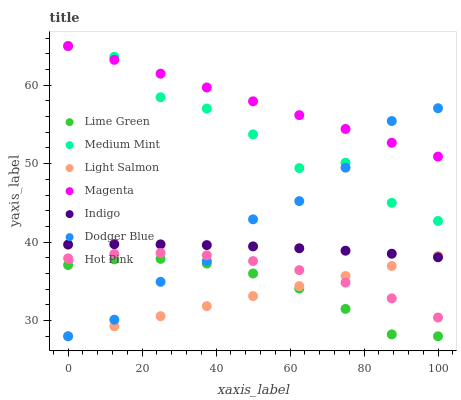Does Light Salmon have the minimum area under the curve?
Answer yes or no. Yes. Does Magenta have the maximum area under the curve?
Answer yes or no. Yes. Does Indigo have the minimum area under the curve?
Answer yes or no. No. Does Indigo have the maximum area under the curve?
Answer yes or no. No. Is Light Salmon the smoothest?
Answer yes or no. Yes. Is Medium Mint the roughest?
Answer yes or no. Yes. Is Indigo the smoothest?
Answer yes or no. No. Is Indigo the roughest?
Answer yes or no. No. Does Light Salmon have the lowest value?
Answer yes or no. Yes. Does Indigo have the lowest value?
Answer yes or no. No. Does Magenta have the highest value?
Answer yes or no. Yes. Does Light Salmon have the highest value?
Answer yes or no. No. Is Hot Pink less than Magenta?
Answer yes or no. Yes. Is Magenta greater than Lime Green?
Answer yes or no. Yes. Does Indigo intersect Light Salmon?
Answer yes or no. Yes. Is Indigo less than Light Salmon?
Answer yes or no. No. Is Indigo greater than Light Salmon?
Answer yes or no. No. Does Hot Pink intersect Magenta?
Answer yes or no. No. 